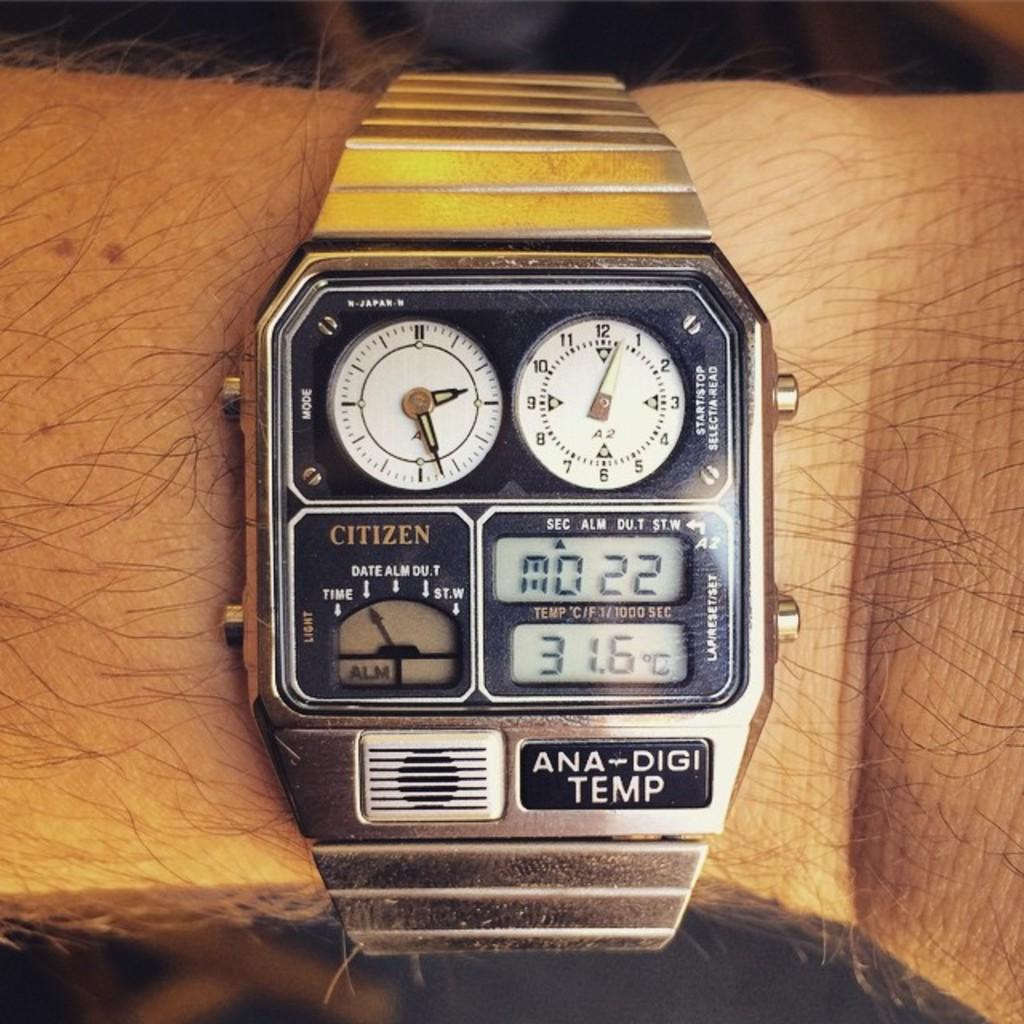<image>
Present a compact description of the photo's key features. An ANA-DIGI Temp shows different times and the temperature. 